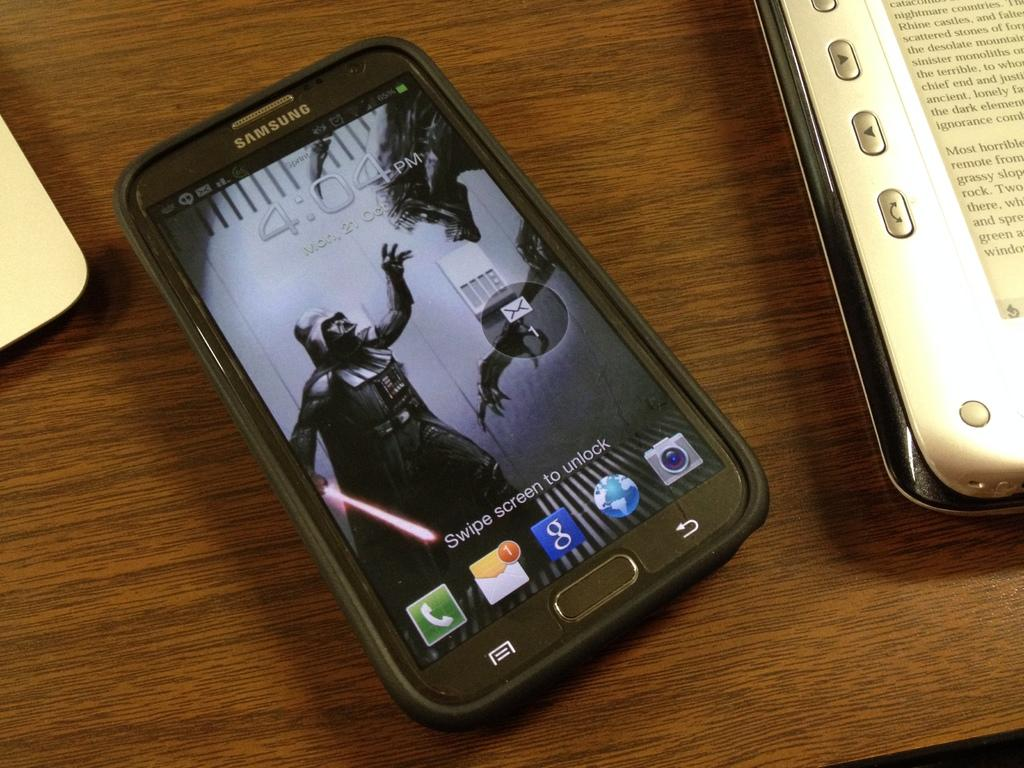<image>
Give a short and clear explanation of the subsequent image. A Samsung phone reads 4:04 pm and says swipe screen to unlock 